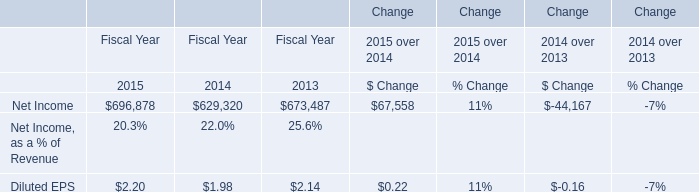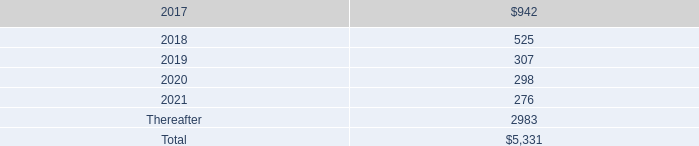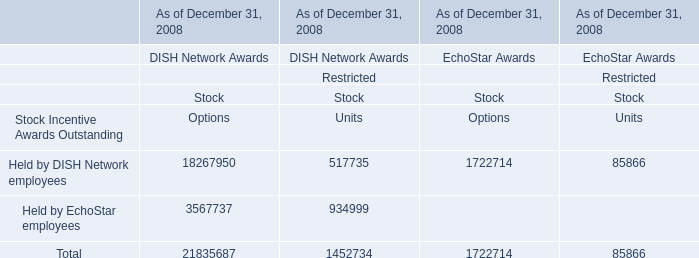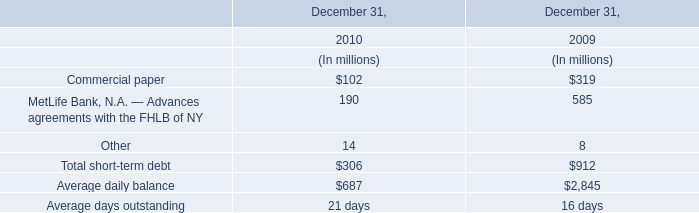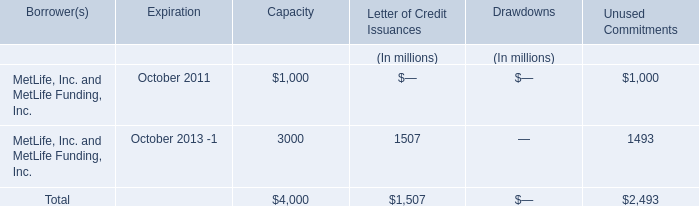what is the percentage of outstanding shares among all issued shares? 
Computations: (217 / 249)
Answer: 0.87149. 